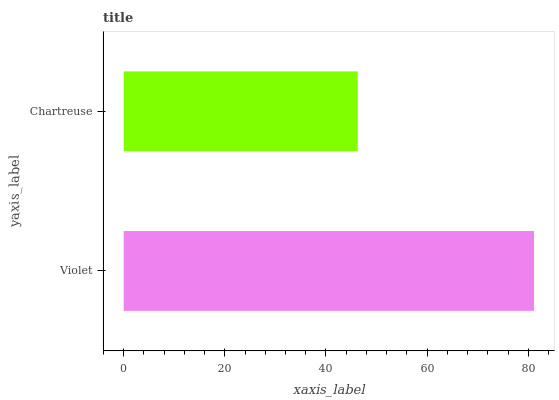Is Chartreuse the minimum?
Answer yes or no. Yes. Is Violet the maximum?
Answer yes or no. Yes. Is Chartreuse the maximum?
Answer yes or no. No. Is Violet greater than Chartreuse?
Answer yes or no. Yes. Is Chartreuse less than Violet?
Answer yes or no. Yes. Is Chartreuse greater than Violet?
Answer yes or no. No. Is Violet less than Chartreuse?
Answer yes or no. No. Is Violet the high median?
Answer yes or no. Yes. Is Chartreuse the low median?
Answer yes or no. Yes. Is Chartreuse the high median?
Answer yes or no. No. Is Violet the low median?
Answer yes or no. No. 